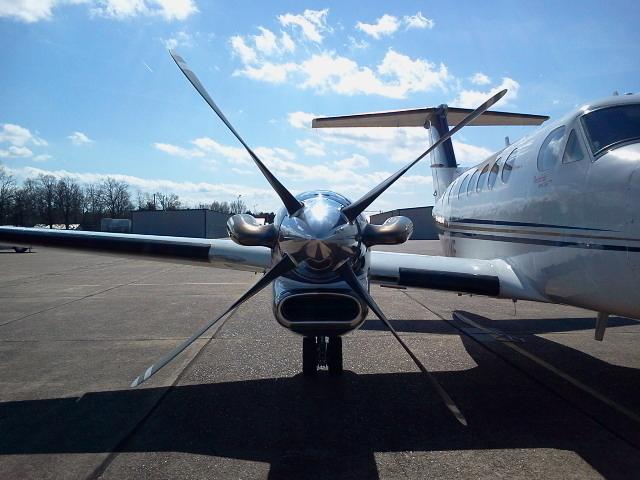Does this machine make a very soft noise?
Give a very brief answer. No. What is this vehicle called?
Quick response, please. Plane. Is this a war aircraft?
Write a very short answer. No. What kind of vehicle is shown in the picture?
Short answer required. Airplane. 